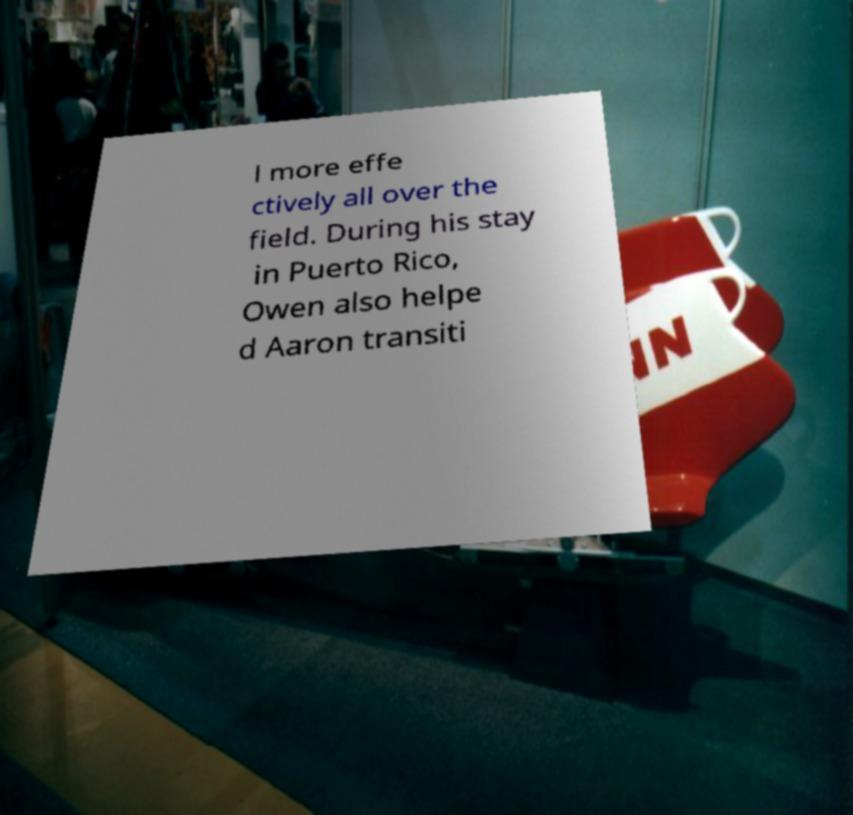I need the written content from this picture converted into text. Can you do that? l more effe ctively all over the field. During his stay in Puerto Rico, Owen also helpe d Aaron transiti 